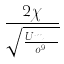<formula> <loc_0><loc_0><loc_500><loc_500>\frac { 2 \chi } { \sqrt { \frac { U m _ { s e n } } { o ^ { 9 } } } }</formula> 